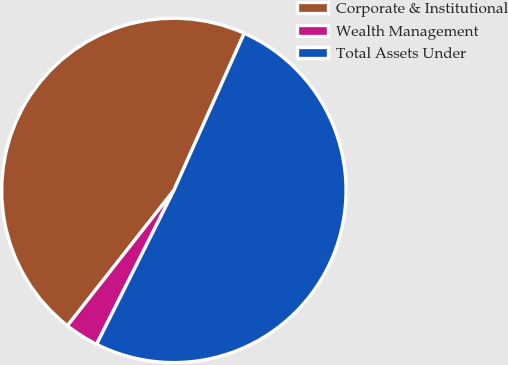Convert chart. <chart><loc_0><loc_0><loc_500><loc_500><pie_chart><fcel>Corporate & Institutional<fcel>Wealth Management<fcel>Total Assets Under<nl><fcel>46.1%<fcel>3.2%<fcel>50.71%<nl></chart> 